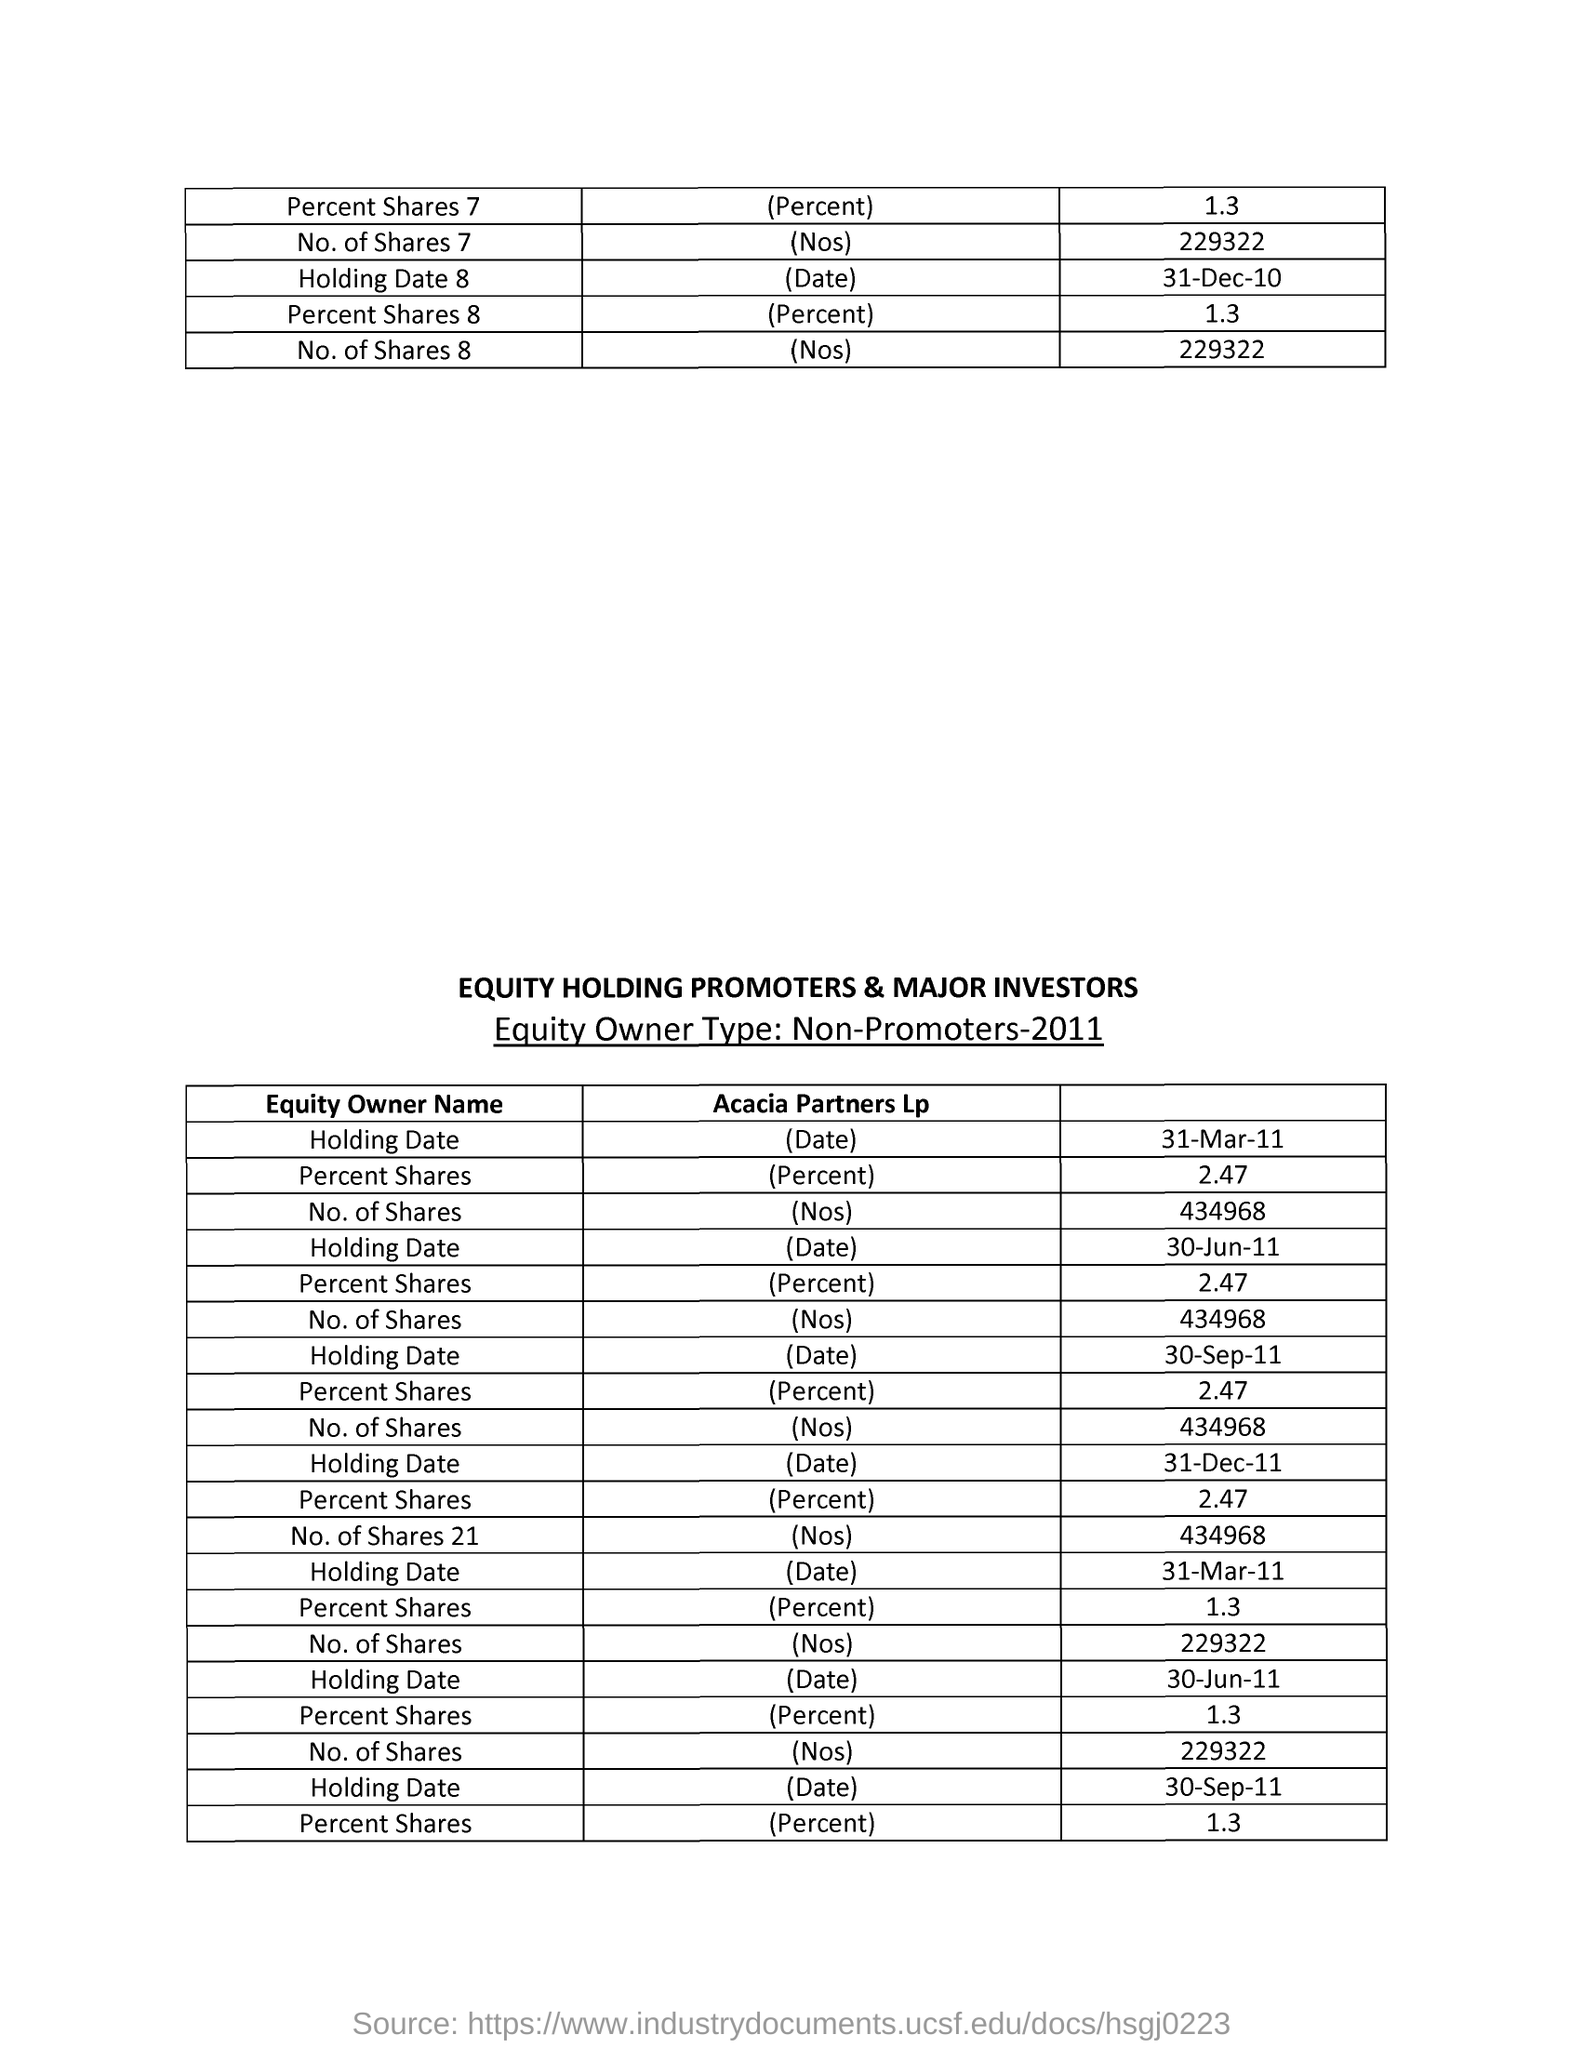List a handful of essential elements in this visual. In 2011, the year in which equity owners of a company were classified as non-promoters, the ownership structure of the company was significantly different from previous years. The total number of shares in Acacia Partners LP is 21. 